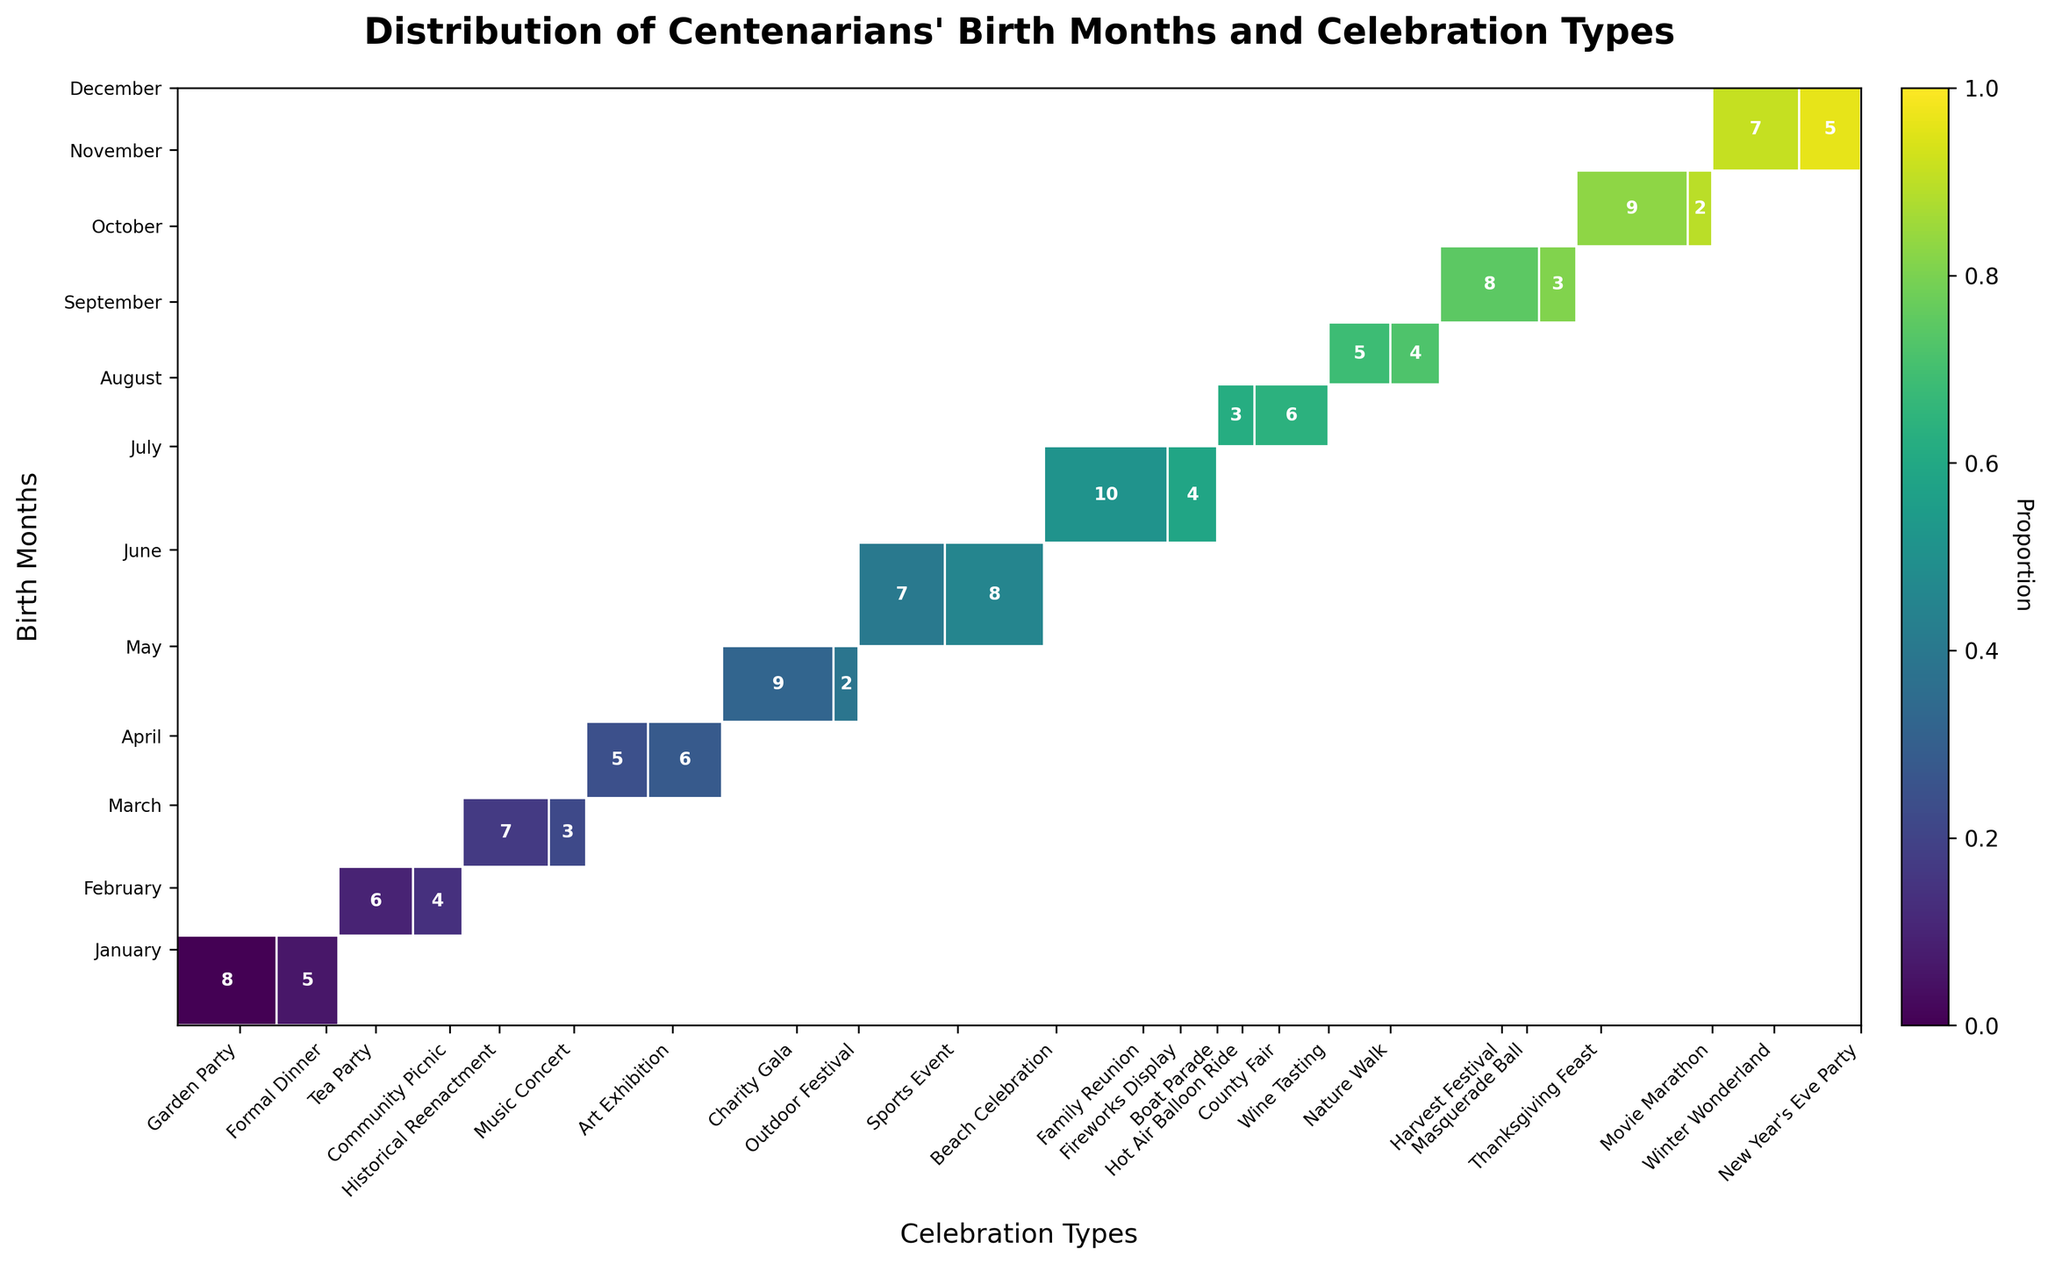In which month are most centenarians born? Looking at the y-axis and the height of the rectangles, July has the highest total height indicating the most centenarians are born in that month.
Answer: July Which celebration type is most preferred by centenarians in July? Within the rectangles corresponding to July, Fireworks Display is the tallest, meaning it is the most preferred celebration type that month.
Answer: Fireworks Display How does the preference for Outdoor Festival differ between May and other months? In the mosaic plot, the height of the rectangle for Outdoor Festival in May is higher compared to any other month, showing a strong preference in May.
Answer: Highest in May Does any month share an equal preference for two different celebration types? By comparing the heights of the rectangles within the same month, December shows a relatively equal preference between Winter Wonderland and New Year's Eve Party, though Winter Wonderland is slightly preferred.
Answer: December What celebration type is least preferred for centenarians born in November? Within the November section, the rectangle for Movie Marathon is the smallest, indicating it is the least preferred celebration type in November.
Answer: Movie Marathon Compare the preference for Music Concert in March to that in other months. The rectangle height for Music Concert in March is higher than in any other month, indicating it is most preferred in March.
Answer: Highest in March How many centenarians prefer a Garden Party in January? From the rectangle in January for Garden Party, the text inside the rectangle shows the count as 8.
Answer: 8 Which month has the least preference for a Formal Dinner? The rectangle height for Formal Dinner is visible only in January, indicating no other month has a preference for it, making all other months least preferred.
Answer: Any month but January Compare the preference for a Family Reunion in June to other celebration types in the same month. In June, the rectangle for Family Reunion is higher than for Beach Celebration, indicating a stronger preference for Family Reunion.
Answer: Family Reunion How does the combined preference for Thanksgiving Feast and Movie Marathon in November compare to total celebration counts in December? Adding the rectangle heights in November for Thanksgiving Feast (9) and Movie Marathon (2) gives a combined total of 11, which is higher than the total counts in December (7 for Winter Wonderland and 5 for New Year’s Eve Party, totaling 12). So, December is slightly higher overall.
Answer: Slightly higher in December 